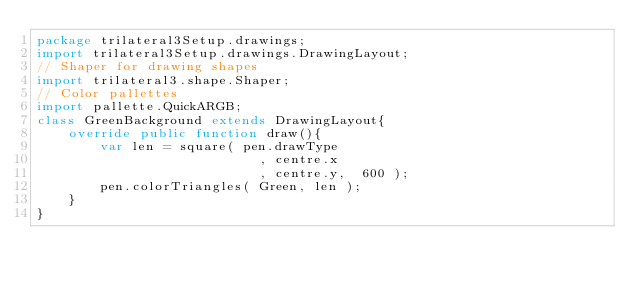Convert code to text. <code><loc_0><loc_0><loc_500><loc_500><_Haxe_>package trilateral3Setup.drawings;
import trilateral3Setup.drawings.DrawingLayout;
// Shaper for drawing shapes
import trilateral3.shape.Shaper;
// Color pallettes
import pallette.QuickARGB;
class GreenBackground extends DrawingLayout{
    override public function draw(){
        var len = square( pen.drawType
                            , centre.x
                            , centre.y,  600 );
        pen.colorTriangles( Green, len );
    }
}</code> 